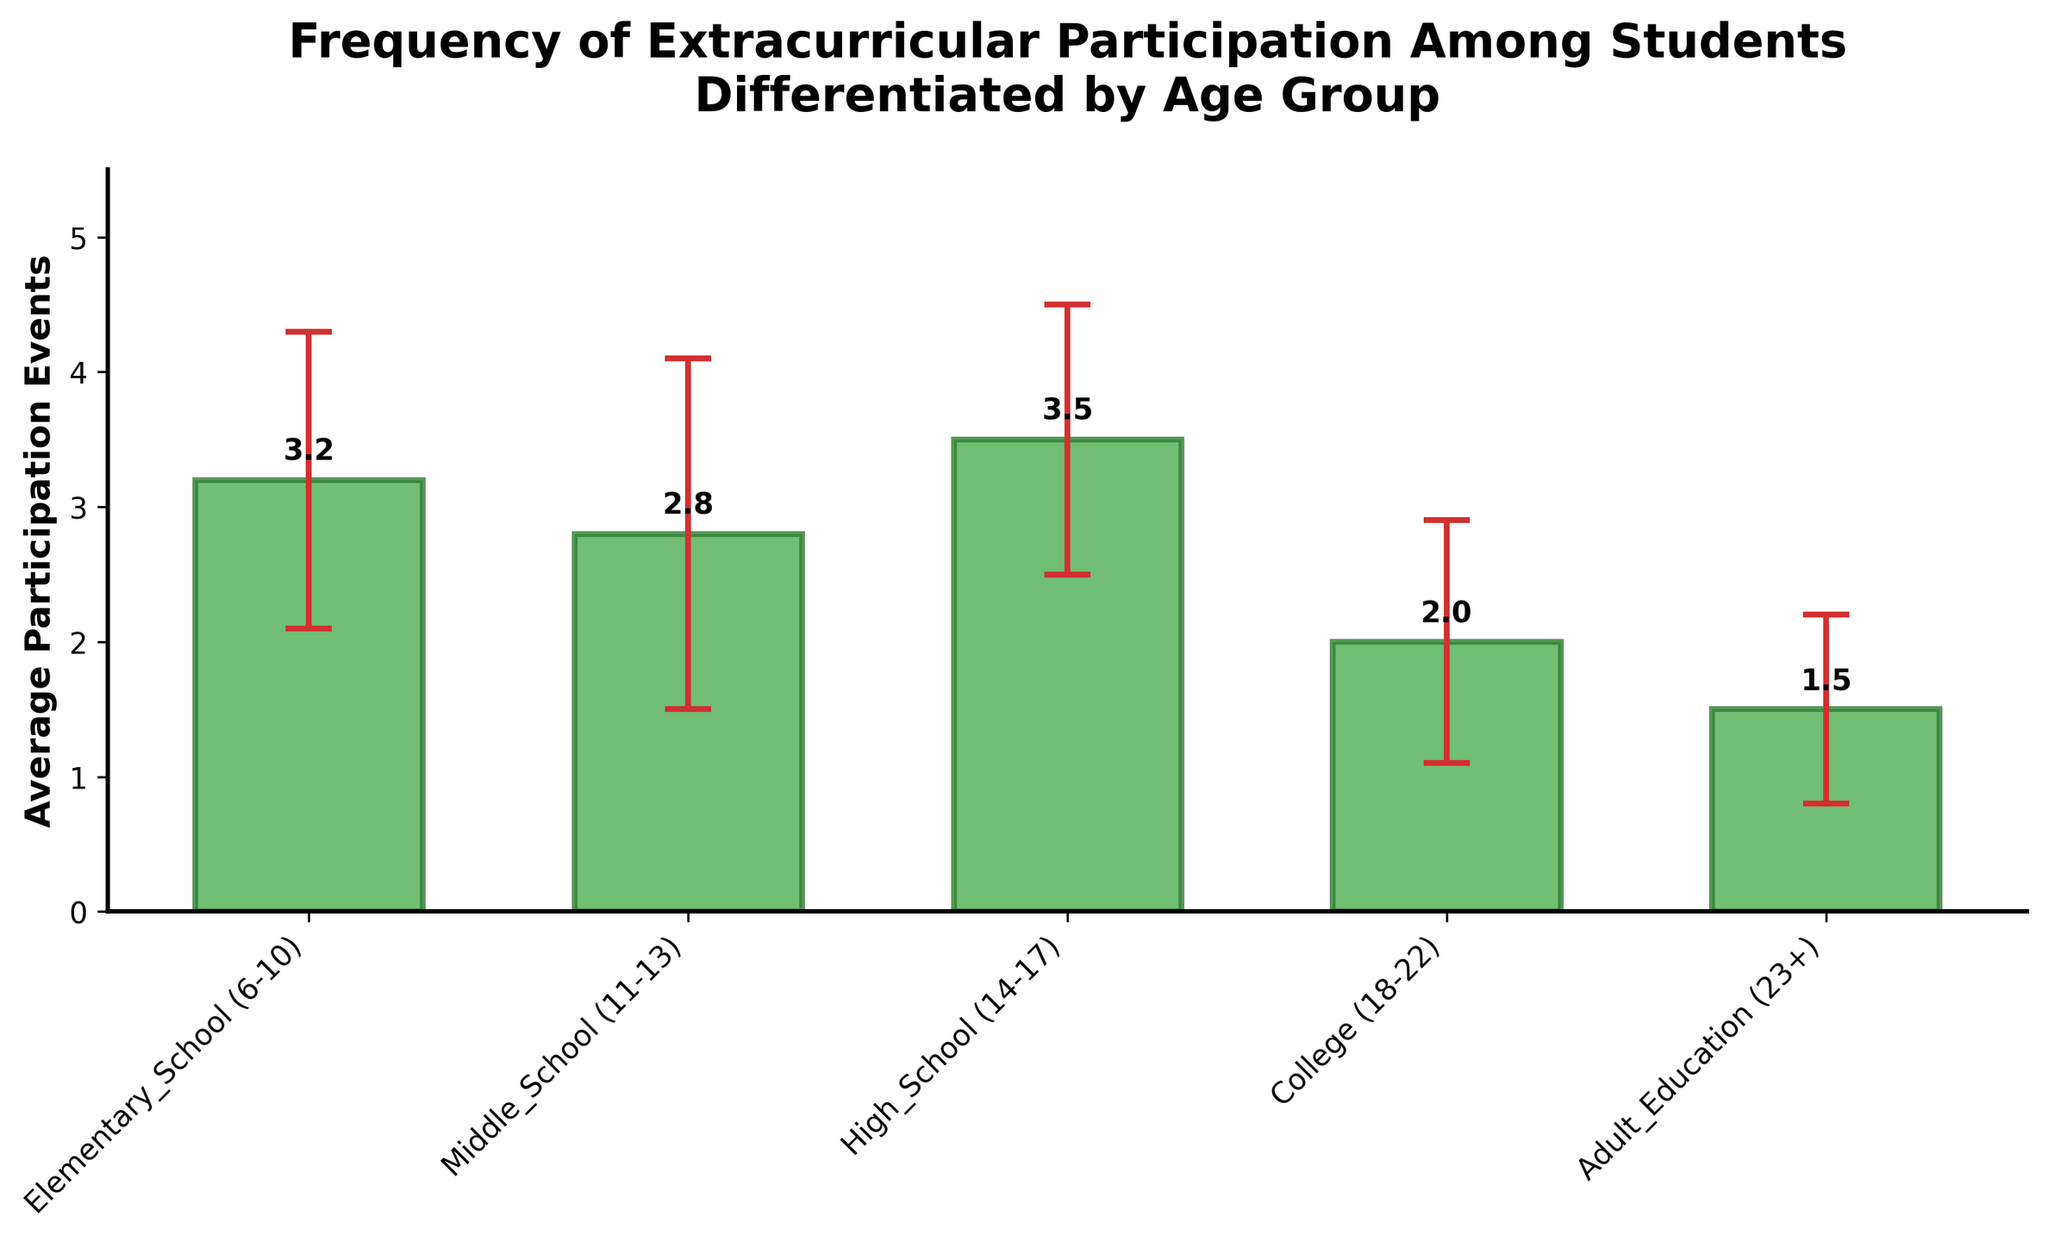What's the title of the figure? The title is prominently displayed at the top of the bar chart.
Answer: Frequency of Extracurricular Participation Among Students Differentiated by Age Group How many age groups are represented in the figure? Count the distinct bars labeled along the x-axis. There are five unique bars corresponding to the different age groups.
Answer: 5 Which age group has the highest average participation events? Look for the bar that reaches the highest value on the y-axis. The bar labeled "High School (14-17)" is the tallest.
Answer: High School (14-17) What is the average participation for College students? Locate the bar labeled "College (18-22)" and read the numeric value directly on top of the bar.
Answer: 2.0 What's the difference in average participation events between Elementary School students and Adult Education participants? Subtract the average participation of Adult Education (1.5) from that of Elementary School (3.2).
Answer: 1.7 Which age group has the smallest standard deviation in participation events? Compare the error bars for each age group. The "Adult Education (23+)" group has the smallest error bars.
Answer: Adult Education (23+) Rank the age groups from highest to lowest average participation. Order the age groups by the height of their bars. High School (3.5), Elementary School (3.2), Middle School (2.8), College (2.0), Adult Education (1.5).
Answer: High School > Elementary School > Middle School > College > Adult Education What's the sum of average participation events for Middle School and High School students? Add the averages for Middle School (2.8) and High School (3.5).
Answer: 6.3 Does any age group have an average participation event below 2? Check each bar if its value is less than 2. Only the "Adult Education" group has a value below 2 (1.5).
Answer: Yes For which age group is there the greatest variability in participation events? Locate the age group with the largest standard deviation/error bar. "Middle School (11-13)" has the largest error bar (1.3).
Answer: Middle School (11-13) 